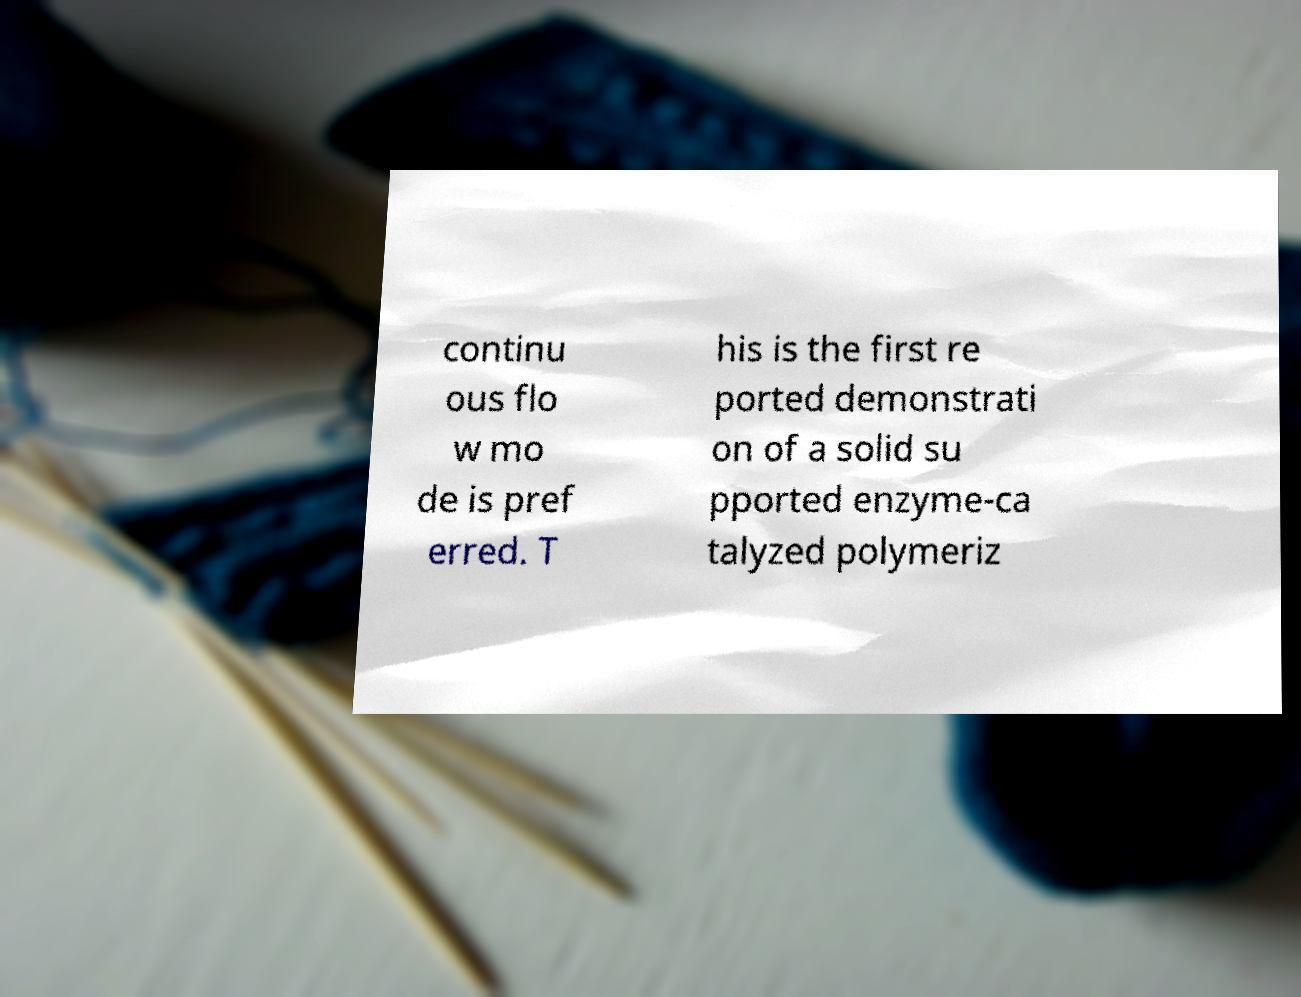There's text embedded in this image that I need extracted. Can you transcribe it verbatim? continu ous flo w mo de is pref erred. T his is the first re ported demonstrati on of a solid su pported enzyme-ca talyzed polymeriz 